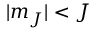<formula> <loc_0><loc_0><loc_500><loc_500>| m _ { J } | < J</formula> 